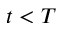Convert formula to latex. <formula><loc_0><loc_0><loc_500><loc_500>t < T</formula> 